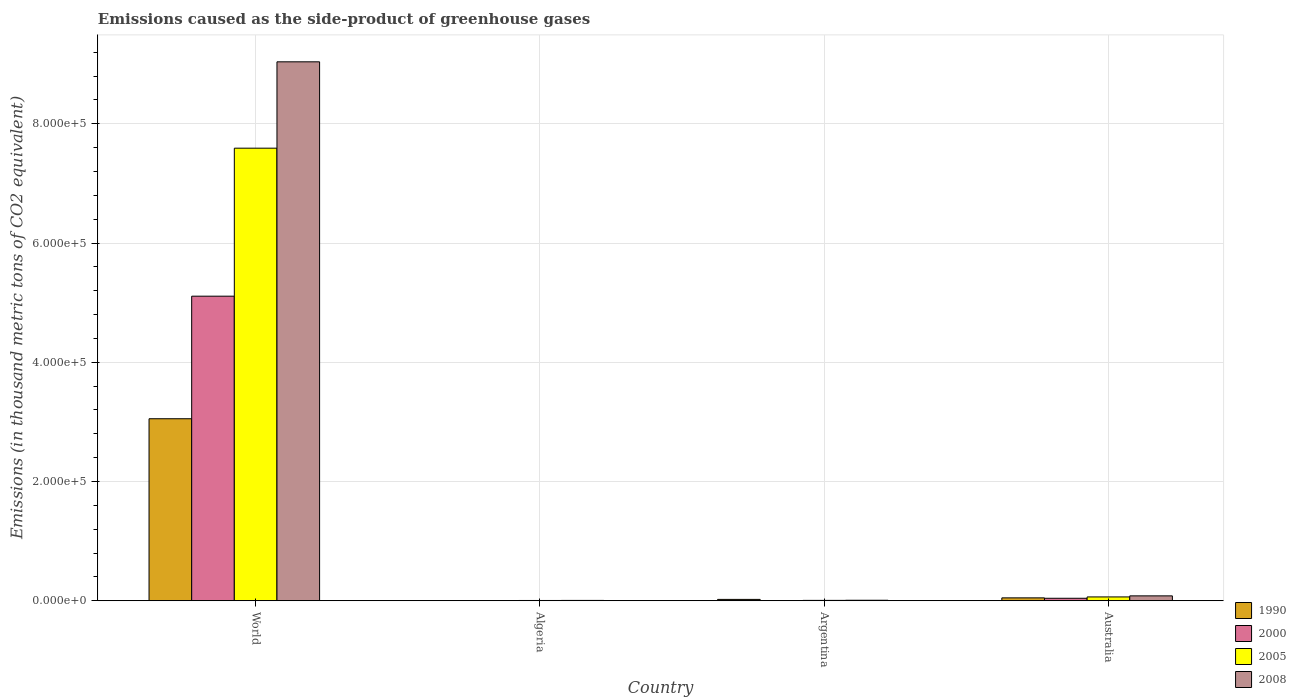How many different coloured bars are there?
Make the answer very short. 4. How many groups of bars are there?
Your answer should be compact. 4. Are the number of bars per tick equal to the number of legend labels?
Your response must be concise. Yes. Are the number of bars on each tick of the X-axis equal?
Offer a terse response. Yes. How many bars are there on the 2nd tick from the right?
Your answer should be compact. 4. What is the label of the 4th group of bars from the left?
Keep it short and to the point. Australia. What is the emissions caused as the side-product of greenhouse gases in 1990 in Algeria?
Your answer should be compact. 326. Across all countries, what is the maximum emissions caused as the side-product of greenhouse gases in 2005?
Provide a short and direct response. 7.59e+05. Across all countries, what is the minimum emissions caused as the side-product of greenhouse gases in 1990?
Give a very brief answer. 326. In which country was the emissions caused as the side-product of greenhouse gases in 2005 minimum?
Offer a terse response. Algeria. What is the total emissions caused as the side-product of greenhouse gases in 1990 in the graph?
Provide a short and direct response. 3.13e+05. What is the difference between the emissions caused as the side-product of greenhouse gases in 2005 in Algeria and that in Australia?
Your answer should be compact. -5972.2. What is the difference between the emissions caused as the side-product of greenhouse gases in 2008 in Algeria and the emissions caused as the side-product of greenhouse gases in 2005 in Argentina?
Make the answer very short. -51. What is the average emissions caused as the side-product of greenhouse gases in 2005 per country?
Make the answer very short. 1.92e+05. What is the difference between the emissions caused as the side-product of greenhouse gases of/in 1990 and emissions caused as the side-product of greenhouse gases of/in 2005 in World?
Make the answer very short. -4.54e+05. What is the ratio of the emissions caused as the side-product of greenhouse gases in 2005 in Australia to that in World?
Provide a succinct answer. 0.01. What is the difference between the highest and the second highest emissions caused as the side-product of greenhouse gases in 1990?
Your answer should be compact. -3.00e+05. What is the difference between the highest and the lowest emissions caused as the side-product of greenhouse gases in 2005?
Provide a succinct answer. 7.59e+05. What does the 3rd bar from the left in Australia represents?
Keep it short and to the point. 2005. What does the 3rd bar from the right in Australia represents?
Make the answer very short. 2000. Is it the case that in every country, the sum of the emissions caused as the side-product of greenhouse gases in 2000 and emissions caused as the side-product of greenhouse gases in 1990 is greater than the emissions caused as the side-product of greenhouse gases in 2008?
Your response must be concise. No. How many bars are there?
Your answer should be very brief. 16. Are all the bars in the graph horizontal?
Your answer should be very brief. No. How many countries are there in the graph?
Make the answer very short. 4. Does the graph contain any zero values?
Your answer should be compact. No. Does the graph contain grids?
Provide a succinct answer. Yes. Where does the legend appear in the graph?
Your response must be concise. Bottom right. How many legend labels are there?
Your response must be concise. 4. What is the title of the graph?
Offer a very short reply. Emissions caused as the side-product of greenhouse gases. What is the label or title of the Y-axis?
Provide a succinct answer. Emissions (in thousand metric tons of CO2 equivalent). What is the Emissions (in thousand metric tons of CO2 equivalent) of 1990 in World?
Your answer should be compact. 3.05e+05. What is the Emissions (in thousand metric tons of CO2 equivalent) in 2000 in World?
Keep it short and to the point. 5.11e+05. What is the Emissions (in thousand metric tons of CO2 equivalent) in 2005 in World?
Offer a very short reply. 7.59e+05. What is the Emissions (in thousand metric tons of CO2 equivalent) in 2008 in World?
Offer a very short reply. 9.04e+05. What is the Emissions (in thousand metric tons of CO2 equivalent) in 1990 in Algeria?
Your answer should be compact. 326. What is the Emissions (in thousand metric tons of CO2 equivalent) in 2000 in Algeria?
Provide a short and direct response. 371.9. What is the Emissions (in thousand metric tons of CO2 equivalent) of 2005 in Algeria?
Your answer should be very brief. 487.4. What is the Emissions (in thousand metric tons of CO2 equivalent) of 2008 in Algeria?
Your answer should be very brief. 613.9. What is the Emissions (in thousand metric tons of CO2 equivalent) in 1990 in Argentina?
Your response must be concise. 2296.5. What is the Emissions (in thousand metric tons of CO2 equivalent) in 2000 in Argentina?
Ensure brevity in your answer.  408.8. What is the Emissions (in thousand metric tons of CO2 equivalent) in 2005 in Argentina?
Offer a terse response. 664.9. What is the Emissions (in thousand metric tons of CO2 equivalent) of 2008 in Argentina?
Provide a short and direct response. 872.4. What is the Emissions (in thousand metric tons of CO2 equivalent) in 1990 in Australia?
Give a very brief answer. 4872.8. What is the Emissions (in thousand metric tons of CO2 equivalent) in 2000 in Australia?
Provide a short and direct response. 4198.3. What is the Emissions (in thousand metric tons of CO2 equivalent) in 2005 in Australia?
Make the answer very short. 6459.6. What is the Emissions (in thousand metric tons of CO2 equivalent) in 2008 in Australia?
Offer a terse response. 8243.5. Across all countries, what is the maximum Emissions (in thousand metric tons of CO2 equivalent) of 1990?
Keep it short and to the point. 3.05e+05. Across all countries, what is the maximum Emissions (in thousand metric tons of CO2 equivalent) of 2000?
Ensure brevity in your answer.  5.11e+05. Across all countries, what is the maximum Emissions (in thousand metric tons of CO2 equivalent) of 2005?
Your answer should be very brief. 7.59e+05. Across all countries, what is the maximum Emissions (in thousand metric tons of CO2 equivalent) of 2008?
Your response must be concise. 9.04e+05. Across all countries, what is the minimum Emissions (in thousand metric tons of CO2 equivalent) in 1990?
Offer a terse response. 326. Across all countries, what is the minimum Emissions (in thousand metric tons of CO2 equivalent) of 2000?
Offer a very short reply. 371.9. Across all countries, what is the minimum Emissions (in thousand metric tons of CO2 equivalent) of 2005?
Your response must be concise. 487.4. Across all countries, what is the minimum Emissions (in thousand metric tons of CO2 equivalent) of 2008?
Your response must be concise. 613.9. What is the total Emissions (in thousand metric tons of CO2 equivalent) in 1990 in the graph?
Make the answer very short. 3.13e+05. What is the total Emissions (in thousand metric tons of CO2 equivalent) in 2000 in the graph?
Provide a succinct answer. 5.16e+05. What is the total Emissions (in thousand metric tons of CO2 equivalent) of 2005 in the graph?
Ensure brevity in your answer.  7.67e+05. What is the total Emissions (in thousand metric tons of CO2 equivalent) in 2008 in the graph?
Your response must be concise. 9.14e+05. What is the difference between the Emissions (in thousand metric tons of CO2 equivalent) of 1990 in World and that in Algeria?
Offer a terse response. 3.05e+05. What is the difference between the Emissions (in thousand metric tons of CO2 equivalent) of 2000 in World and that in Algeria?
Provide a succinct answer. 5.11e+05. What is the difference between the Emissions (in thousand metric tons of CO2 equivalent) of 2005 in World and that in Algeria?
Your answer should be compact. 7.59e+05. What is the difference between the Emissions (in thousand metric tons of CO2 equivalent) of 2008 in World and that in Algeria?
Give a very brief answer. 9.03e+05. What is the difference between the Emissions (in thousand metric tons of CO2 equivalent) in 1990 in World and that in Argentina?
Give a very brief answer. 3.03e+05. What is the difference between the Emissions (in thousand metric tons of CO2 equivalent) in 2000 in World and that in Argentina?
Offer a terse response. 5.10e+05. What is the difference between the Emissions (in thousand metric tons of CO2 equivalent) of 2005 in World and that in Argentina?
Give a very brief answer. 7.58e+05. What is the difference between the Emissions (in thousand metric tons of CO2 equivalent) of 2008 in World and that in Argentina?
Offer a very short reply. 9.03e+05. What is the difference between the Emissions (in thousand metric tons of CO2 equivalent) in 1990 in World and that in Australia?
Offer a terse response. 3.00e+05. What is the difference between the Emissions (in thousand metric tons of CO2 equivalent) in 2000 in World and that in Australia?
Keep it short and to the point. 5.07e+05. What is the difference between the Emissions (in thousand metric tons of CO2 equivalent) in 2005 in World and that in Australia?
Provide a succinct answer. 7.53e+05. What is the difference between the Emissions (in thousand metric tons of CO2 equivalent) of 2008 in World and that in Australia?
Keep it short and to the point. 8.96e+05. What is the difference between the Emissions (in thousand metric tons of CO2 equivalent) of 1990 in Algeria and that in Argentina?
Ensure brevity in your answer.  -1970.5. What is the difference between the Emissions (in thousand metric tons of CO2 equivalent) of 2000 in Algeria and that in Argentina?
Give a very brief answer. -36.9. What is the difference between the Emissions (in thousand metric tons of CO2 equivalent) in 2005 in Algeria and that in Argentina?
Make the answer very short. -177.5. What is the difference between the Emissions (in thousand metric tons of CO2 equivalent) of 2008 in Algeria and that in Argentina?
Your response must be concise. -258.5. What is the difference between the Emissions (in thousand metric tons of CO2 equivalent) in 1990 in Algeria and that in Australia?
Give a very brief answer. -4546.8. What is the difference between the Emissions (in thousand metric tons of CO2 equivalent) in 2000 in Algeria and that in Australia?
Offer a terse response. -3826.4. What is the difference between the Emissions (in thousand metric tons of CO2 equivalent) in 2005 in Algeria and that in Australia?
Make the answer very short. -5972.2. What is the difference between the Emissions (in thousand metric tons of CO2 equivalent) of 2008 in Algeria and that in Australia?
Make the answer very short. -7629.6. What is the difference between the Emissions (in thousand metric tons of CO2 equivalent) in 1990 in Argentina and that in Australia?
Offer a very short reply. -2576.3. What is the difference between the Emissions (in thousand metric tons of CO2 equivalent) in 2000 in Argentina and that in Australia?
Keep it short and to the point. -3789.5. What is the difference between the Emissions (in thousand metric tons of CO2 equivalent) of 2005 in Argentina and that in Australia?
Provide a succinct answer. -5794.7. What is the difference between the Emissions (in thousand metric tons of CO2 equivalent) in 2008 in Argentina and that in Australia?
Offer a terse response. -7371.1. What is the difference between the Emissions (in thousand metric tons of CO2 equivalent) of 1990 in World and the Emissions (in thousand metric tons of CO2 equivalent) of 2000 in Algeria?
Provide a succinct answer. 3.05e+05. What is the difference between the Emissions (in thousand metric tons of CO2 equivalent) of 1990 in World and the Emissions (in thousand metric tons of CO2 equivalent) of 2005 in Algeria?
Make the answer very short. 3.05e+05. What is the difference between the Emissions (in thousand metric tons of CO2 equivalent) of 1990 in World and the Emissions (in thousand metric tons of CO2 equivalent) of 2008 in Algeria?
Offer a very short reply. 3.05e+05. What is the difference between the Emissions (in thousand metric tons of CO2 equivalent) of 2000 in World and the Emissions (in thousand metric tons of CO2 equivalent) of 2005 in Algeria?
Your answer should be very brief. 5.10e+05. What is the difference between the Emissions (in thousand metric tons of CO2 equivalent) in 2000 in World and the Emissions (in thousand metric tons of CO2 equivalent) in 2008 in Algeria?
Ensure brevity in your answer.  5.10e+05. What is the difference between the Emissions (in thousand metric tons of CO2 equivalent) of 2005 in World and the Emissions (in thousand metric tons of CO2 equivalent) of 2008 in Algeria?
Make the answer very short. 7.59e+05. What is the difference between the Emissions (in thousand metric tons of CO2 equivalent) of 1990 in World and the Emissions (in thousand metric tons of CO2 equivalent) of 2000 in Argentina?
Keep it short and to the point. 3.05e+05. What is the difference between the Emissions (in thousand metric tons of CO2 equivalent) in 1990 in World and the Emissions (in thousand metric tons of CO2 equivalent) in 2005 in Argentina?
Make the answer very short. 3.05e+05. What is the difference between the Emissions (in thousand metric tons of CO2 equivalent) of 1990 in World and the Emissions (in thousand metric tons of CO2 equivalent) of 2008 in Argentina?
Offer a very short reply. 3.04e+05. What is the difference between the Emissions (in thousand metric tons of CO2 equivalent) of 2000 in World and the Emissions (in thousand metric tons of CO2 equivalent) of 2005 in Argentina?
Your answer should be very brief. 5.10e+05. What is the difference between the Emissions (in thousand metric tons of CO2 equivalent) of 2000 in World and the Emissions (in thousand metric tons of CO2 equivalent) of 2008 in Argentina?
Your answer should be compact. 5.10e+05. What is the difference between the Emissions (in thousand metric tons of CO2 equivalent) in 2005 in World and the Emissions (in thousand metric tons of CO2 equivalent) in 2008 in Argentina?
Provide a short and direct response. 7.58e+05. What is the difference between the Emissions (in thousand metric tons of CO2 equivalent) in 1990 in World and the Emissions (in thousand metric tons of CO2 equivalent) in 2000 in Australia?
Provide a succinct answer. 3.01e+05. What is the difference between the Emissions (in thousand metric tons of CO2 equivalent) of 1990 in World and the Emissions (in thousand metric tons of CO2 equivalent) of 2005 in Australia?
Provide a succinct answer. 2.99e+05. What is the difference between the Emissions (in thousand metric tons of CO2 equivalent) of 1990 in World and the Emissions (in thousand metric tons of CO2 equivalent) of 2008 in Australia?
Provide a succinct answer. 2.97e+05. What is the difference between the Emissions (in thousand metric tons of CO2 equivalent) of 2000 in World and the Emissions (in thousand metric tons of CO2 equivalent) of 2005 in Australia?
Offer a terse response. 5.04e+05. What is the difference between the Emissions (in thousand metric tons of CO2 equivalent) of 2000 in World and the Emissions (in thousand metric tons of CO2 equivalent) of 2008 in Australia?
Your answer should be very brief. 5.03e+05. What is the difference between the Emissions (in thousand metric tons of CO2 equivalent) in 2005 in World and the Emissions (in thousand metric tons of CO2 equivalent) in 2008 in Australia?
Your answer should be compact. 7.51e+05. What is the difference between the Emissions (in thousand metric tons of CO2 equivalent) in 1990 in Algeria and the Emissions (in thousand metric tons of CO2 equivalent) in 2000 in Argentina?
Give a very brief answer. -82.8. What is the difference between the Emissions (in thousand metric tons of CO2 equivalent) of 1990 in Algeria and the Emissions (in thousand metric tons of CO2 equivalent) of 2005 in Argentina?
Your answer should be very brief. -338.9. What is the difference between the Emissions (in thousand metric tons of CO2 equivalent) of 1990 in Algeria and the Emissions (in thousand metric tons of CO2 equivalent) of 2008 in Argentina?
Give a very brief answer. -546.4. What is the difference between the Emissions (in thousand metric tons of CO2 equivalent) in 2000 in Algeria and the Emissions (in thousand metric tons of CO2 equivalent) in 2005 in Argentina?
Keep it short and to the point. -293. What is the difference between the Emissions (in thousand metric tons of CO2 equivalent) of 2000 in Algeria and the Emissions (in thousand metric tons of CO2 equivalent) of 2008 in Argentina?
Give a very brief answer. -500.5. What is the difference between the Emissions (in thousand metric tons of CO2 equivalent) of 2005 in Algeria and the Emissions (in thousand metric tons of CO2 equivalent) of 2008 in Argentina?
Make the answer very short. -385. What is the difference between the Emissions (in thousand metric tons of CO2 equivalent) of 1990 in Algeria and the Emissions (in thousand metric tons of CO2 equivalent) of 2000 in Australia?
Ensure brevity in your answer.  -3872.3. What is the difference between the Emissions (in thousand metric tons of CO2 equivalent) in 1990 in Algeria and the Emissions (in thousand metric tons of CO2 equivalent) in 2005 in Australia?
Your answer should be very brief. -6133.6. What is the difference between the Emissions (in thousand metric tons of CO2 equivalent) in 1990 in Algeria and the Emissions (in thousand metric tons of CO2 equivalent) in 2008 in Australia?
Ensure brevity in your answer.  -7917.5. What is the difference between the Emissions (in thousand metric tons of CO2 equivalent) of 2000 in Algeria and the Emissions (in thousand metric tons of CO2 equivalent) of 2005 in Australia?
Provide a succinct answer. -6087.7. What is the difference between the Emissions (in thousand metric tons of CO2 equivalent) of 2000 in Algeria and the Emissions (in thousand metric tons of CO2 equivalent) of 2008 in Australia?
Keep it short and to the point. -7871.6. What is the difference between the Emissions (in thousand metric tons of CO2 equivalent) of 2005 in Algeria and the Emissions (in thousand metric tons of CO2 equivalent) of 2008 in Australia?
Offer a terse response. -7756.1. What is the difference between the Emissions (in thousand metric tons of CO2 equivalent) in 1990 in Argentina and the Emissions (in thousand metric tons of CO2 equivalent) in 2000 in Australia?
Give a very brief answer. -1901.8. What is the difference between the Emissions (in thousand metric tons of CO2 equivalent) of 1990 in Argentina and the Emissions (in thousand metric tons of CO2 equivalent) of 2005 in Australia?
Offer a terse response. -4163.1. What is the difference between the Emissions (in thousand metric tons of CO2 equivalent) in 1990 in Argentina and the Emissions (in thousand metric tons of CO2 equivalent) in 2008 in Australia?
Offer a terse response. -5947. What is the difference between the Emissions (in thousand metric tons of CO2 equivalent) in 2000 in Argentina and the Emissions (in thousand metric tons of CO2 equivalent) in 2005 in Australia?
Give a very brief answer. -6050.8. What is the difference between the Emissions (in thousand metric tons of CO2 equivalent) in 2000 in Argentina and the Emissions (in thousand metric tons of CO2 equivalent) in 2008 in Australia?
Provide a succinct answer. -7834.7. What is the difference between the Emissions (in thousand metric tons of CO2 equivalent) in 2005 in Argentina and the Emissions (in thousand metric tons of CO2 equivalent) in 2008 in Australia?
Offer a terse response. -7578.6. What is the average Emissions (in thousand metric tons of CO2 equivalent) in 1990 per country?
Provide a short and direct response. 7.82e+04. What is the average Emissions (in thousand metric tons of CO2 equivalent) in 2000 per country?
Offer a very short reply. 1.29e+05. What is the average Emissions (in thousand metric tons of CO2 equivalent) in 2005 per country?
Offer a very short reply. 1.92e+05. What is the average Emissions (in thousand metric tons of CO2 equivalent) of 2008 per country?
Ensure brevity in your answer.  2.28e+05. What is the difference between the Emissions (in thousand metric tons of CO2 equivalent) of 1990 and Emissions (in thousand metric tons of CO2 equivalent) of 2000 in World?
Offer a terse response. -2.06e+05. What is the difference between the Emissions (in thousand metric tons of CO2 equivalent) of 1990 and Emissions (in thousand metric tons of CO2 equivalent) of 2005 in World?
Keep it short and to the point. -4.54e+05. What is the difference between the Emissions (in thousand metric tons of CO2 equivalent) of 1990 and Emissions (in thousand metric tons of CO2 equivalent) of 2008 in World?
Offer a terse response. -5.99e+05. What is the difference between the Emissions (in thousand metric tons of CO2 equivalent) in 2000 and Emissions (in thousand metric tons of CO2 equivalent) in 2005 in World?
Ensure brevity in your answer.  -2.48e+05. What is the difference between the Emissions (in thousand metric tons of CO2 equivalent) of 2000 and Emissions (in thousand metric tons of CO2 equivalent) of 2008 in World?
Keep it short and to the point. -3.93e+05. What is the difference between the Emissions (in thousand metric tons of CO2 equivalent) in 2005 and Emissions (in thousand metric tons of CO2 equivalent) in 2008 in World?
Ensure brevity in your answer.  -1.45e+05. What is the difference between the Emissions (in thousand metric tons of CO2 equivalent) in 1990 and Emissions (in thousand metric tons of CO2 equivalent) in 2000 in Algeria?
Give a very brief answer. -45.9. What is the difference between the Emissions (in thousand metric tons of CO2 equivalent) of 1990 and Emissions (in thousand metric tons of CO2 equivalent) of 2005 in Algeria?
Provide a short and direct response. -161.4. What is the difference between the Emissions (in thousand metric tons of CO2 equivalent) in 1990 and Emissions (in thousand metric tons of CO2 equivalent) in 2008 in Algeria?
Ensure brevity in your answer.  -287.9. What is the difference between the Emissions (in thousand metric tons of CO2 equivalent) of 2000 and Emissions (in thousand metric tons of CO2 equivalent) of 2005 in Algeria?
Offer a very short reply. -115.5. What is the difference between the Emissions (in thousand metric tons of CO2 equivalent) in 2000 and Emissions (in thousand metric tons of CO2 equivalent) in 2008 in Algeria?
Give a very brief answer. -242. What is the difference between the Emissions (in thousand metric tons of CO2 equivalent) in 2005 and Emissions (in thousand metric tons of CO2 equivalent) in 2008 in Algeria?
Your answer should be very brief. -126.5. What is the difference between the Emissions (in thousand metric tons of CO2 equivalent) in 1990 and Emissions (in thousand metric tons of CO2 equivalent) in 2000 in Argentina?
Your response must be concise. 1887.7. What is the difference between the Emissions (in thousand metric tons of CO2 equivalent) in 1990 and Emissions (in thousand metric tons of CO2 equivalent) in 2005 in Argentina?
Keep it short and to the point. 1631.6. What is the difference between the Emissions (in thousand metric tons of CO2 equivalent) of 1990 and Emissions (in thousand metric tons of CO2 equivalent) of 2008 in Argentina?
Offer a very short reply. 1424.1. What is the difference between the Emissions (in thousand metric tons of CO2 equivalent) of 2000 and Emissions (in thousand metric tons of CO2 equivalent) of 2005 in Argentina?
Provide a succinct answer. -256.1. What is the difference between the Emissions (in thousand metric tons of CO2 equivalent) of 2000 and Emissions (in thousand metric tons of CO2 equivalent) of 2008 in Argentina?
Your answer should be very brief. -463.6. What is the difference between the Emissions (in thousand metric tons of CO2 equivalent) in 2005 and Emissions (in thousand metric tons of CO2 equivalent) in 2008 in Argentina?
Provide a succinct answer. -207.5. What is the difference between the Emissions (in thousand metric tons of CO2 equivalent) in 1990 and Emissions (in thousand metric tons of CO2 equivalent) in 2000 in Australia?
Make the answer very short. 674.5. What is the difference between the Emissions (in thousand metric tons of CO2 equivalent) of 1990 and Emissions (in thousand metric tons of CO2 equivalent) of 2005 in Australia?
Ensure brevity in your answer.  -1586.8. What is the difference between the Emissions (in thousand metric tons of CO2 equivalent) of 1990 and Emissions (in thousand metric tons of CO2 equivalent) of 2008 in Australia?
Your answer should be compact. -3370.7. What is the difference between the Emissions (in thousand metric tons of CO2 equivalent) in 2000 and Emissions (in thousand metric tons of CO2 equivalent) in 2005 in Australia?
Offer a terse response. -2261.3. What is the difference between the Emissions (in thousand metric tons of CO2 equivalent) in 2000 and Emissions (in thousand metric tons of CO2 equivalent) in 2008 in Australia?
Keep it short and to the point. -4045.2. What is the difference between the Emissions (in thousand metric tons of CO2 equivalent) in 2005 and Emissions (in thousand metric tons of CO2 equivalent) in 2008 in Australia?
Your answer should be very brief. -1783.9. What is the ratio of the Emissions (in thousand metric tons of CO2 equivalent) in 1990 in World to that in Algeria?
Provide a short and direct response. 936.6. What is the ratio of the Emissions (in thousand metric tons of CO2 equivalent) in 2000 in World to that in Algeria?
Offer a very short reply. 1373.76. What is the ratio of the Emissions (in thousand metric tons of CO2 equivalent) in 2005 in World to that in Algeria?
Give a very brief answer. 1557.54. What is the ratio of the Emissions (in thousand metric tons of CO2 equivalent) of 2008 in World to that in Algeria?
Your answer should be compact. 1472.53. What is the ratio of the Emissions (in thousand metric tons of CO2 equivalent) in 1990 in World to that in Argentina?
Provide a succinct answer. 132.95. What is the ratio of the Emissions (in thousand metric tons of CO2 equivalent) of 2000 in World to that in Argentina?
Your answer should be compact. 1249.76. What is the ratio of the Emissions (in thousand metric tons of CO2 equivalent) of 2005 in World to that in Argentina?
Make the answer very short. 1141.74. What is the ratio of the Emissions (in thousand metric tons of CO2 equivalent) in 2008 in World to that in Argentina?
Provide a succinct answer. 1036.2. What is the ratio of the Emissions (in thousand metric tons of CO2 equivalent) of 1990 in World to that in Australia?
Your answer should be very brief. 62.66. What is the ratio of the Emissions (in thousand metric tons of CO2 equivalent) of 2000 in World to that in Australia?
Make the answer very short. 121.69. What is the ratio of the Emissions (in thousand metric tons of CO2 equivalent) in 2005 in World to that in Australia?
Your answer should be very brief. 117.52. What is the ratio of the Emissions (in thousand metric tons of CO2 equivalent) of 2008 in World to that in Australia?
Offer a terse response. 109.66. What is the ratio of the Emissions (in thousand metric tons of CO2 equivalent) of 1990 in Algeria to that in Argentina?
Provide a succinct answer. 0.14. What is the ratio of the Emissions (in thousand metric tons of CO2 equivalent) in 2000 in Algeria to that in Argentina?
Offer a very short reply. 0.91. What is the ratio of the Emissions (in thousand metric tons of CO2 equivalent) in 2005 in Algeria to that in Argentina?
Offer a very short reply. 0.73. What is the ratio of the Emissions (in thousand metric tons of CO2 equivalent) in 2008 in Algeria to that in Argentina?
Offer a very short reply. 0.7. What is the ratio of the Emissions (in thousand metric tons of CO2 equivalent) of 1990 in Algeria to that in Australia?
Your response must be concise. 0.07. What is the ratio of the Emissions (in thousand metric tons of CO2 equivalent) in 2000 in Algeria to that in Australia?
Give a very brief answer. 0.09. What is the ratio of the Emissions (in thousand metric tons of CO2 equivalent) of 2005 in Algeria to that in Australia?
Make the answer very short. 0.08. What is the ratio of the Emissions (in thousand metric tons of CO2 equivalent) of 2008 in Algeria to that in Australia?
Offer a terse response. 0.07. What is the ratio of the Emissions (in thousand metric tons of CO2 equivalent) in 1990 in Argentina to that in Australia?
Provide a succinct answer. 0.47. What is the ratio of the Emissions (in thousand metric tons of CO2 equivalent) of 2000 in Argentina to that in Australia?
Your answer should be compact. 0.1. What is the ratio of the Emissions (in thousand metric tons of CO2 equivalent) of 2005 in Argentina to that in Australia?
Your response must be concise. 0.1. What is the ratio of the Emissions (in thousand metric tons of CO2 equivalent) in 2008 in Argentina to that in Australia?
Provide a short and direct response. 0.11. What is the difference between the highest and the second highest Emissions (in thousand metric tons of CO2 equivalent) of 1990?
Offer a very short reply. 3.00e+05. What is the difference between the highest and the second highest Emissions (in thousand metric tons of CO2 equivalent) of 2000?
Your answer should be very brief. 5.07e+05. What is the difference between the highest and the second highest Emissions (in thousand metric tons of CO2 equivalent) of 2005?
Offer a terse response. 7.53e+05. What is the difference between the highest and the second highest Emissions (in thousand metric tons of CO2 equivalent) of 2008?
Offer a terse response. 8.96e+05. What is the difference between the highest and the lowest Emissions (in thousand metric tons of CO2 equivalent) of 1990?
Ensure brevity in your answer.  3.05e+05. What is the difference between the highest and the lowest Emissions (in thousand metric tons of CO2 equivalent) in 2000?
Offer a very short reply. 5.11e+05. What is the difference between the highest and the lowest Emissions (in thousand metric tons of CO2 equivalent) of 2005?
Your answer should be compact. 7.59e+05. What is the difference between the highest and the lowest Emissions (in thousand metric tons of CO2 equivalent) of 2008?
Your answer should be very brief. 9.03e+05. 